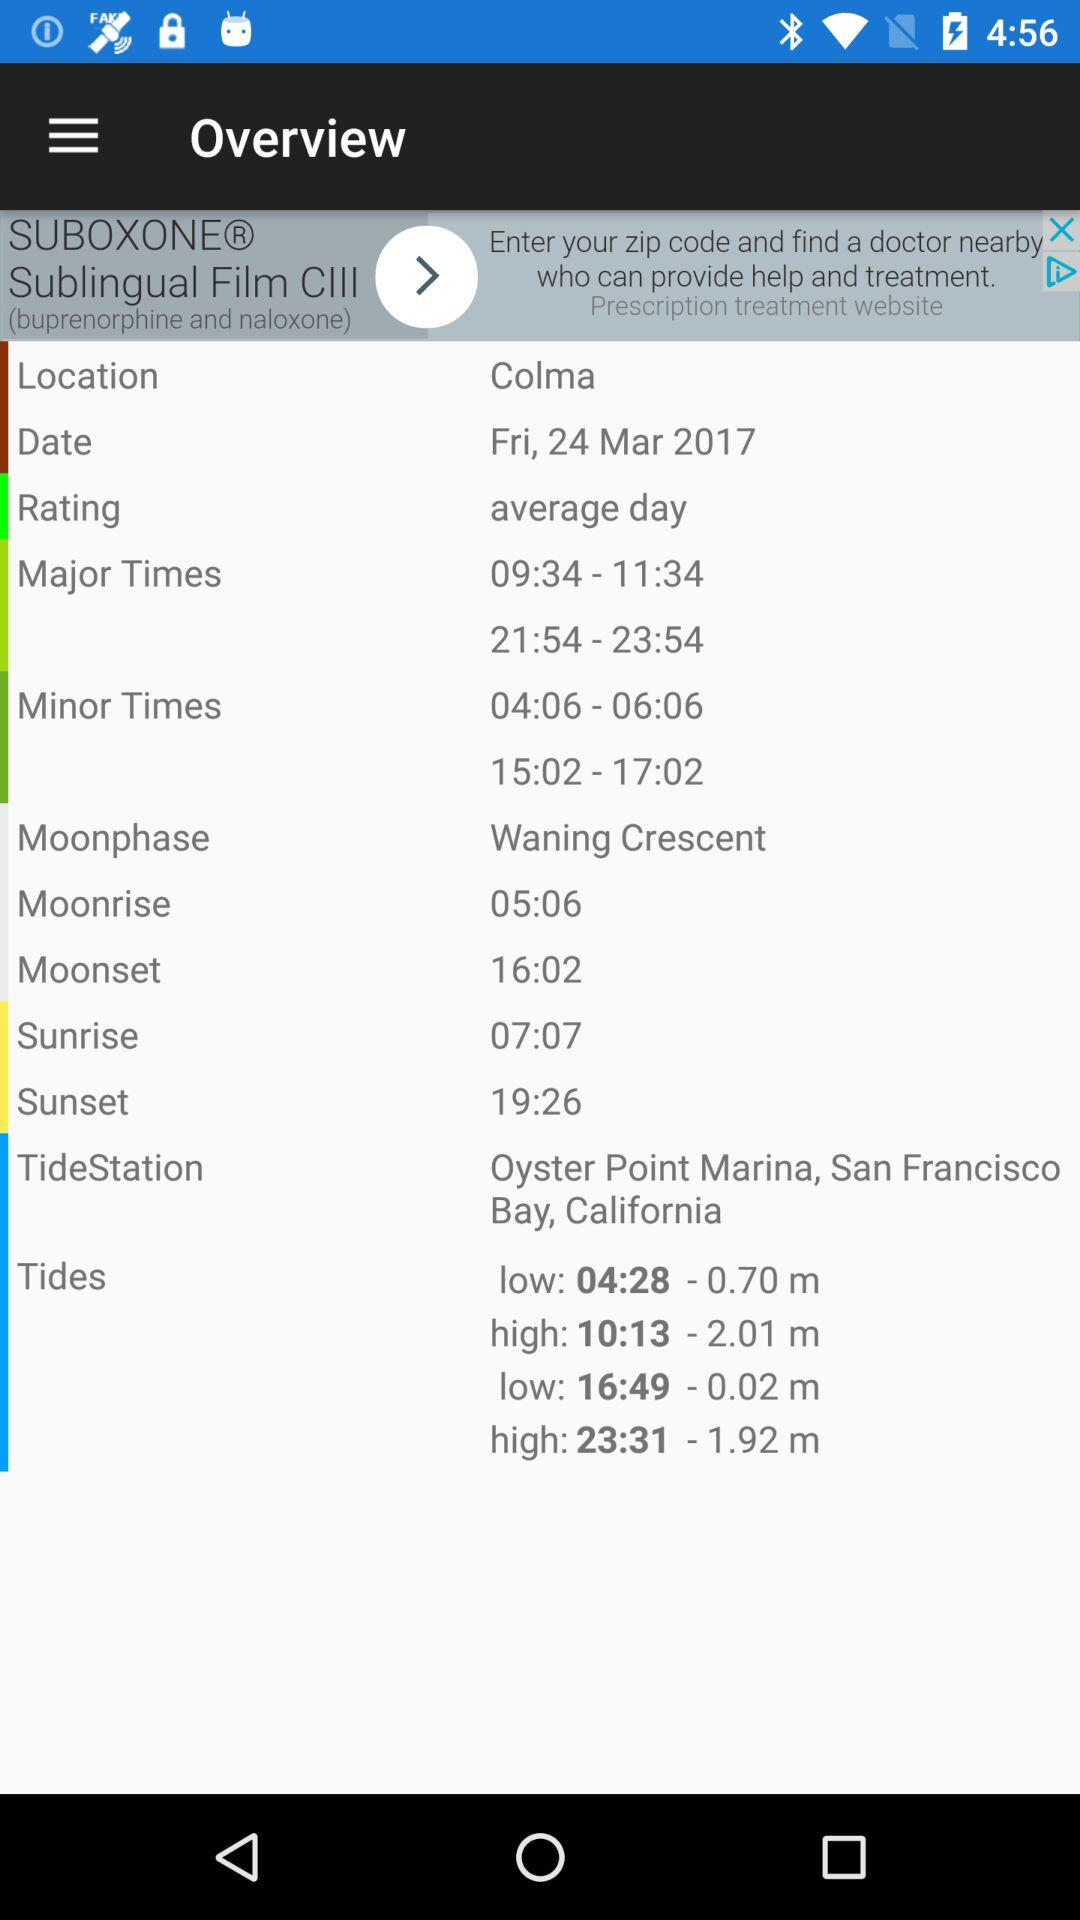What is the rating? The rating is "average day". 